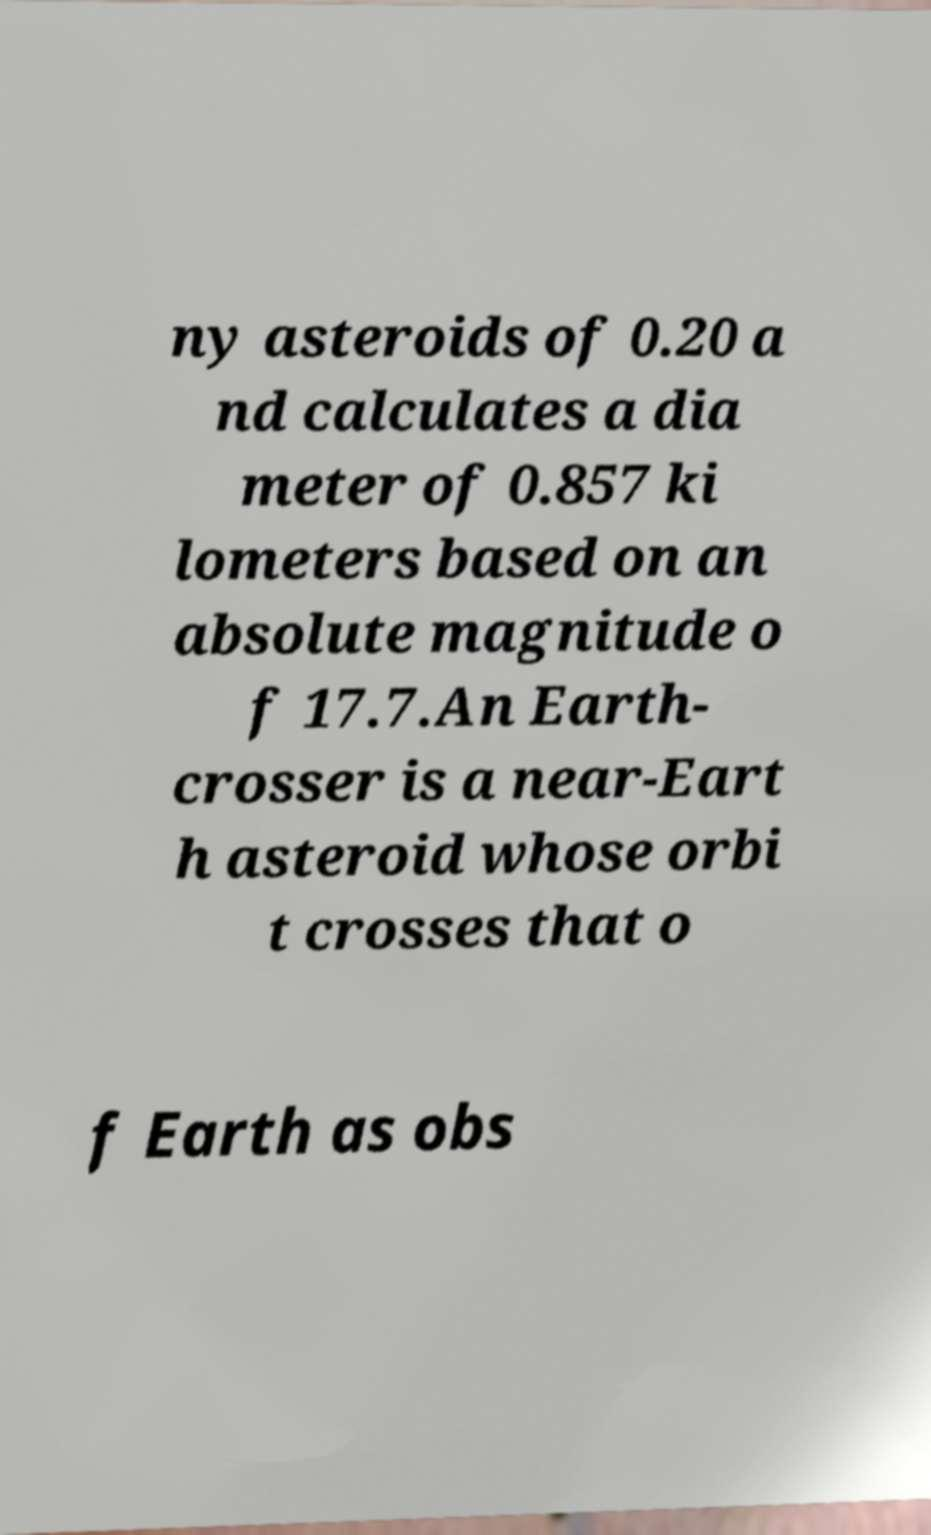I need the written content from this picture converted into text. Can you do that? ny asteroids of 0.20 a nd calculates a dia meter of 0.857 ki lometers based on an absolute magnitude o f 17.7.An Earth- crosser is a near-Eart h asteroid whose orbi t crosses that o f Earth as obs 